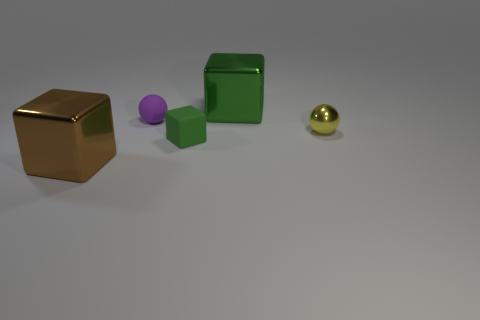What number of objects are blue objects or brown metal things?
Ensure brevity in your answer.  1. What is the shape of the large brown shiny thing?
Ensure brevity in your answer.  Cube. The yellow metal thing that is the same shape as the purple rubber thing is what size?
Offer a very short reply. Small. Is there anything else that is the same material as the purple sphere?
Give a very brief answer. Yes. What is the size of the purple sphere to the left of the large cube behind the tiny yellow metal sphere?
Provide a short and direct response. Small. Are there the same number of green matte things that are in front of the tiny yellow object and yellow blocks?
Your answer should be very brief. No. How many other things are there of the same color as the tiny metal object?
Provide a succinct answer. 0. Is the number of yellow metal spheres that are behind the small yellow thing less than the number of large brown metal objects?
Offer a very short reply. Yes. Is there a shiny cylinder of the same size as the brown metallic block?
Your answer should be compact. No. There is a small block; does it have the same color as the big cube in front of the large green metallic cube?
Provide a succinct answer. No. 